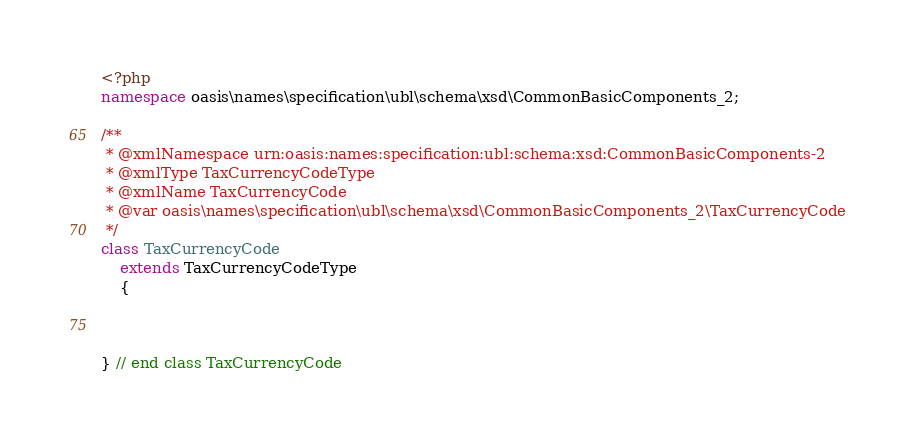<code> <loc_0><loc_0><loc_500><loc_500><_PHP_><?php
namespace oasis\names\specification\ubl\schema\xsd\CommonBasicComponents_2;

/**
 * @xmlNamespace urn:oasis:names:specification:ubl:schema:xsd:CommonBasicComponents-2
 * @xmlType TaxCurrencyCodeType
 * @xmlName TaxCurrencyCode
 * @var oasis\names\specification\ubl\schema\xsd\CommonBasicComponents_2\TaxCurrencyCode
 */
class TaxCurrencyCode
	extends TaxCurrencyCodeType
	{



} // end class TaxCurrencyCode
</code> 